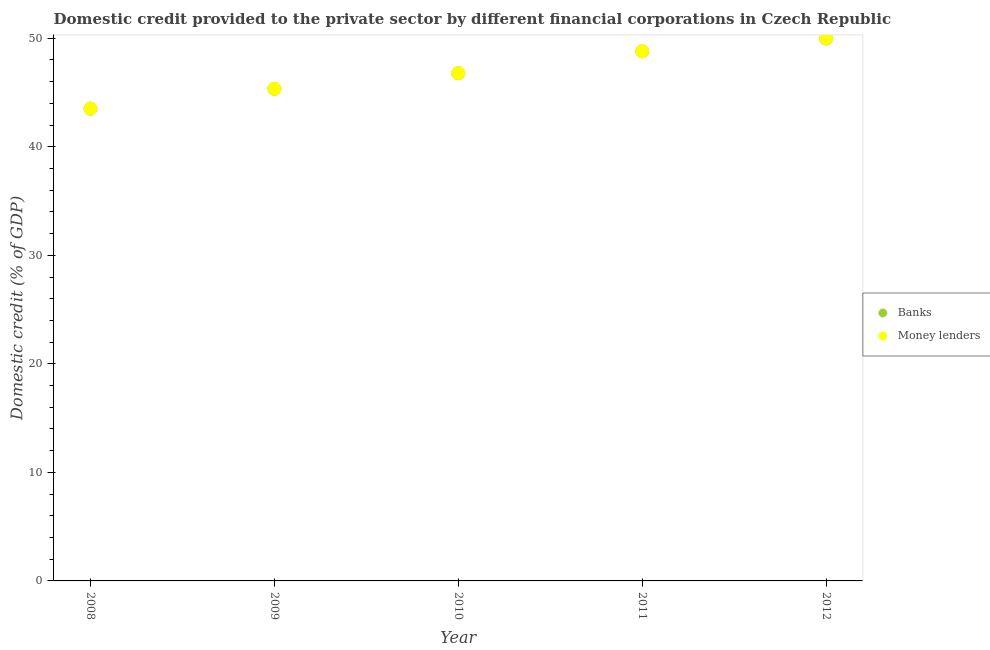Is the number of dotlines equal to the number of legend labels?
Keep it short and to the point. Yes. What is the domestic credit provided by banks in 2010?
Ensure brevity in your answer.  46.78. Across all years, what is the maximum domestic credit provided by money lenders?
Your answer should be very brief. 49.99. Across all years, what is the minimum domestic credit provided by banks?
Make the answer very short. 43.51. In which year was the domestic credit provided by banks maximum?
Provide a succinct answer. 2012. What is the total domestic credit provided by banks in the graph?
Your response must be concise. 234.39. What is the difference between the domestic credit provided by banks in 2009 and that in 2010?
Offer a terse response. -1.44. What is the difference between the domestic credit provided by banks in 2011 and the domestic credit provided by money lenders in 2009?
Your answer should be compact. 3.44. What is the average domestic credit provided by money lenders per year?
Keep it short and to the point. 46.89. In the year 2011, what is the difference between the domestic credit provided by money lenders and domestic credit provided by banks?
Offer a terse response. 0.01. In how many years, is the domestic credit provided by money lenders greater than 30 %?
Provide a short and direct response. 5. What is the ratio of the domestic credit provided by money lenders in 2010 to that in 2011?
Your answer should be compact. 0.96. Is the domestic credit provided by money lenders in 2008 less than that in 2009?
Offer a terse response. Yes. Is the difference between the domestic credit provided by banks in 2008 and 2011 greater than the difference between the domestic credit provided by money lenders in 2008 and 2011?
Make the answer very short. No. What is the difference between the highest and the second highest domestic credit provided by banks?
Keep it short and to the point. 1.19. What is the difference between the highest and the lowest domestic credit provided by money lenders?
Your answer should be very brief. 6.46. Does the domestic credit provided by banks monotonically increase over the years?
Your answer should be compact. Yes. Is the domestic credit provided by banks strictly less than the domestic credit provided by money lenders over the years?
Keep it short and to the point. Yes. How many dotlines are there?
Your answer should be compact. 2. What is the difference between two consecutive major ticks on the Y-axis?
Offer a terse response. 10. How many legend labels are there?
Provide a succinct answer. 2. How are the legend labels stacked?
Provide a succinct answer. Vertical. What is the title of the graph?
Your response must be concise. Domestic credit provided to the private sector by different financial corporations in Czech Republic. Does "Banks" appear as one of the legend labels in the graph?
Make the answer very short. Yes. What is the label or title of the Y-axis?
Your answer should be very brief. Domestic credit (% of GDP). What is the Domestic credit (% of GDP) in Banks in 2008?
Provide a succinct answer. 43.51. What is the Domestic credit (% of GDP) of Money lenders in 2008?
Ensure brevity in your answer.  43.52. What is the Domestic credit (% of GDP) in Banks in 2009?
Provide a short and direct response. 45.34. What is the Domestic credit (% of GDP) in Money lenders in 2009?
Your response must be concise. 45.35. What is the Domestic credit (% of GDP) in Banks in 2010?
Provide a succinct answer. 46.78. What is the Domestic credit (% of GDP) of Money lenders in 2010?
Your answer should be compact. 46.79. What is the Domestic credit (% of GDP) of Banks in 2011?
Your answer should be very brief. 48.79. What is the Domestic credit (% of GDP) of Money lenders in 2011?
Make the answer very short. 48.8. What is the Domestic credit (% of GDP) in Banks in 2012?
Your answer should be very brief. 49.98. What is the Domestic credit (% of GDP) in Money lenders in 2012?
Offer a terse response. 49.99. Across all years, what is the maximum Domestic credit (% of GDP) in Banks?
Provide a succinct answer. 49.98. Across all years, what is the maximum Domestic credit (% of GDP) of Money lenders?
Your answer should be very brief. 49.99. Across all years, what is the minimum Domestic credit (% of GDP) of Banks?
Make the answer very short. 43.51. Across all years, what is the minimum Domestic credit (% of GDP) of Money lenders?
Your response must be concise. 43.52. What is the total Domestic credit (% of GDP) in Banks in the graph?
Provide a short and direct response. 234.39. What is the total Domestic credit (% of GDP) in Money lenders in the graph?
Your answer should be very brief. 234.45. What is the difference between the Domestic credit (% of GDP) of Banks in 2008 and that in 2009?
Your answer should be very brief. -1.83. What is the difference between the Domestic credit (% of GDP) in Money lenders in 2008 and that in 2009?
Your answer should be very brief. -1.83. What is the difference between the Domestic credit (% of GDP) of Banks in 2008 and that in 2010?
Offer a terse response. -3.27. What is the difference between the Domestic credit (% of GDP) of Money lenders in 2008 and that in 2010?
Offer a very short reply. -3.27. What is the difference between the Domestic credit (% of GDP) of Banks in 2008 and that in 2011?
Ensure brevity in your answer.  -5.28. What is the difference between the Domestic credit (% of GDP) in Money lenders in 2008 and that in 2011?
Provide a succinct answer. -5.28. What is the difference between the Domestic credit (% of GDP) in Banks in 2008 and that in 2012?
Offer a terse response. -6.47. What is the difference between the Domestic credit (% of GDP) in Money lenders in 2008 and that in 2012?
Provide a short and direct response. -6.46. What is the difference between the Domestic credit (% of GDP) in Banks in 2009 and that in 2010?
Give a very brief answer. -1.44. What is the difference between the Domestic credit (% of GDP) in Money lenders in 2009 and that in 2010?
Keep it short and to the point. -1.44. What is the difference between the Domestic credit (% of GDP) of Banks in 2009 and that in 2011?
Make the answer very short. -3.46. What is the difference between the Domestic credit (% of GDP) of Money lenders in 2009 and that in 2011?
Provide a short and direct response. -3.45. What is the difference between the Domestic credit (% of GDP) of Banks in 2009 and that in 2012?
Your answer should be very brief. -4.64. What is the difference between the Domestic credit (% of GDP) of Money lenders in 2009 and that in 2012?
Your response must be concise. -4.64. What is the difference between the Domestic credit (% of GDP) of Banks in 2010 and that in 2011?
Ensure brevity in your answer.  -2.01. What is the difference between the Domestic credit (% of GDP) in Money lenders in 2010 and that in 2011?
Your answer should be compact. -2.01. What is the difference between the Domestic credit (% of GDP) of Banks in 2010 and that in 2012?
Provide a succinct answer. -3.2. What is the difference between the Domestic credit (% of GDP) in Money lenders in 2010 and that in 2012?
Keep it short and to the point. -3.2. What is the difference between the Domestic credit (% of GDP) of Banks in 2011 and that in 2012?
Offer a terse response. -1.19. What is the difference between the Domestic credit (% of GDP) in Money lenders in 2011 and that in 2012?
Your answer should be very brief. -1.19. What is the difference between the Domestic credit (% of GDP) of Banks in 2008 and the Domestic credit (% of GDP) of Money lenders in 2009?
Offer a terse response. -1.84. What is the difference between the Domestic credit (% of GDP) in Banks in 2008 and the Domestic credit (% of GDP) in Money lenders in 2010?
Provide a short and direct response. -3.28. What is the difference between the Domestic credit (% of GDP) of Banks in 2008 and the Domestic credit (% of GDP) of Money lenders in 2011?
Provide a succinct answer. -5.29. What is the difference between the Domestic credit (% of GDP) in Banks in 2008 and the Domestic credit (% of GDP) in Money lenders in 2012?
Offer a terse response. -6.48. What is the difference between the Domestic credit (% of GDP) in Banks in 2009 and the Domestic credit (% of GDP) in Money lenders in 2010?
Provide a succinct answer. -1.45. What is the difference between the Domestic credit (% of GDP) in Banks in 2009 and the Domestic credit (% of GDP) in Money lenders in 2011?
Ensure brevity in your answer.  -3.47. What is the difference between the Domestic credit (% of GDP) in Banks in 2009 and the Domestic credit (% of GDP) in Money lenders in 2012?
Your response must be concise. -4.65. What is the difference between the Domestic credit (% of GDP) in Banks in 2010 and the Domestic credit (% of GDP) in Money lenders in 2011?
Ensure brevity in your answer.  -2.02. What is the difference between the Domestic credit (% of GDP) in Banks in 2010 and the Domestic credit (% of GDP) in Money lenders in 2012?
Provide a short and direct response. -3.21. What is the difference between the Domestic credit (% of GDP) of Banks in 2011 and the Domestic credit (% of GDP) of Money lenders in 2012?
Offer a terse response. -1.2. What is the average Domestic credit (% of GDP) of Banks per year?
Your response must be concise. 46.88. What is the average Domestic credit (% of GDP) of Money lenders per year?
Your response must be concise. 46.89. In the year 2008, what is the difference between the Domestic credit (% of GDP) of Banks and Domestic credit (% of GDP) of Money lenders?
Keep it short and to the point. -0.01. In the year 2009, what is the difference between the Domestic credit (% of GDP) in Banks and Domestic credit (% of GDP) in Money lenders?
Your answer should be very brief. -0.01. In the year 2010, what is the difference between the Domestic credit (% of GDP) in Banks and Domestic credit (% of GDP) in Money lenders?
Provide a short and direct response. -0.01. In the year 2011, what is the difference between the Domestic credit (% of GDP) in Banks and Domestic credit (% of GDP) in Money lenders?
Your answer should be compact. -0.01. In the year 2012, what is the difference between the Domestic credit (% of GDP) of Banks and Domestic credit (% of GDP) of Money lenders?
Give a very brief answer. -0.01. What is the ratio of the Domestic credit (% of GDP) of Banks in 2008 to that in 2009?
Provide a short and direct response. 0.96. What is the ratio of the Domestic credit (% of GDP) in Money lenders in 2008 to that in 2009?
Provide a short and direct response. 0.96. What is the ratio of the Domestic credit (% of GDP) in Banks in 2008 to that in 2010?
Provide a short and direct response. 0.93. What is the ratio of the Domestic credit (% of GDP) of Money lenders in 2008 to that in 2010?
Ensure brevity in your answer.  0.93. What is the ratio of the Domestic credit (% of GDP) of Banks in 2008 to that in 2011?
Your answer should be compact. 0.89. What is the ratio of the Domestic credit (% of GDP) of Money lenders in 2008 to that in 2011?
Provide a short and direct response. 0.89. What is the ratio of the Domestic credit (% of GDP) of Banks in 2008 to that in 2012?
Your answer should be very brief. 0.87. What is the ratio of the Domestic credit (% of GDP) of Money lenders in 2008 to that in 2012?
Provide a short and direct response. 0.87. What is the ratio of the Domestic credit (% of GDP) of Banks in 2009 to that in 2010?
Your answer should be compact. 0.97. What is the ratio of the Domestic credit (% of GDP) of Money lenders in 2009 to that in 2010?
Provide a succinct answer. 0.97. What is the ratio of the Domestic credit (% of GDP) of Banks in 2009 to that in 2011?
Provide a succinct answer. 0.93. What is the ratio of the Domestic credit (% of GDP) in Money lenders in 2009 to that in 2011?
Keep it short and to the point. 0.93. What is the ratio of the Domestic credit (% of GDP) in Banks in 2009 to that in 2012?
Provide a short and direct response. 0.91. What is the ratio of the Domestic credit (% of GDP) of Money lenders in 2009 to that in 2012?
Your answer should be compact. 0.91. What is the ratio of the Domestic credit (% of GDP) in Banks in 2010 to that in 2011?
Provide a short and direct response. 0.96. What is the ratio of the Domestic credit (% of GDP) in Money lenders in 2010 to that in 2011?
Give a very brief answer. 0.96. What is the ratio of the Domestic credit (% of GDP) of Banks in 2010 to that in 2012?
Your response must be concise. 0.94. What is the ratio of the Domestic credit (% of GDP) of Money lenders in 2010 to that in 2012?
Your response must be concise. 0.94. What is the ratio of the Domestic credit (% of GDP) in Banks in 2011 to that in 2012?
Ensure brevity in your answer.  0.98. What is the ratio of the Domestic credit (% of GDP) of Money lenders in 2011 to that in 2012?
Give a very brief answer. 0.98. What is the difference between the highest and the second highest Domestic credit (% of GDP) of Banks?
Make the answer very short. 1.19. What is the difference between the highest and the second highest Domestic credit (% of GDP) of Money lenders?
Offer a terse response. 1.19. What is the difference between the highest and the lowest Domestic credit (% of GDP) of Banks?
Ensure brevity in your answer.  6.47. What is the difference between the highest and the lowest Domestic credit (% of GDP) of Money lenders?
Make the answer very short. 6.46. 